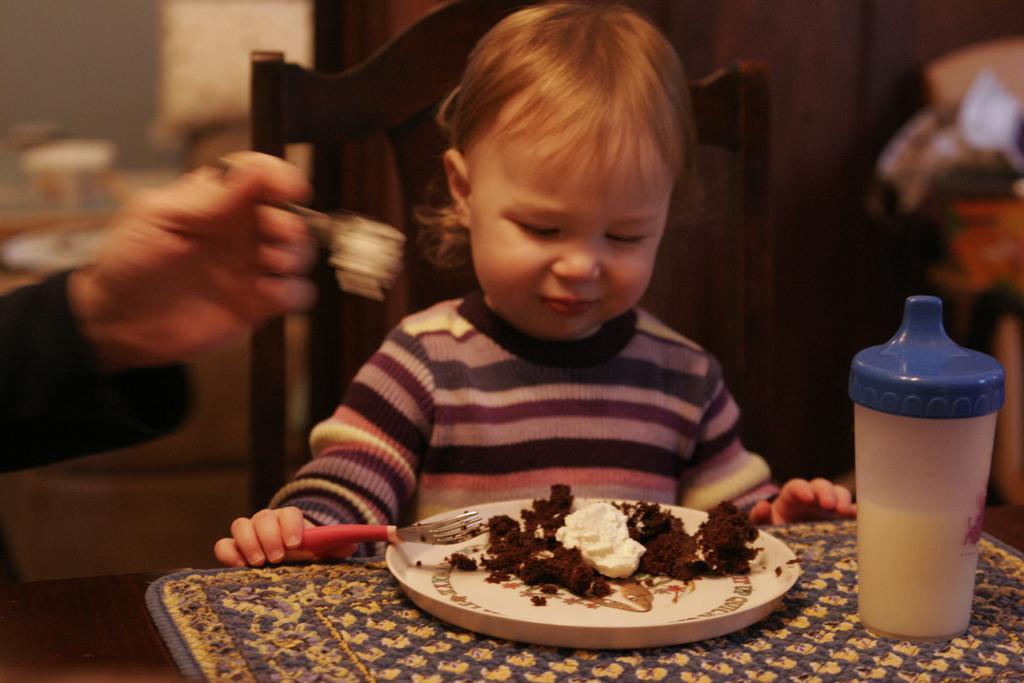Can you describe this image briefly? In this image there is a hand of a person holding an object on the left corner. There are objects on the right corner. There is a chair, a person, there is a food in the plate and there is an object in the foreground. And there are objects in the background. 